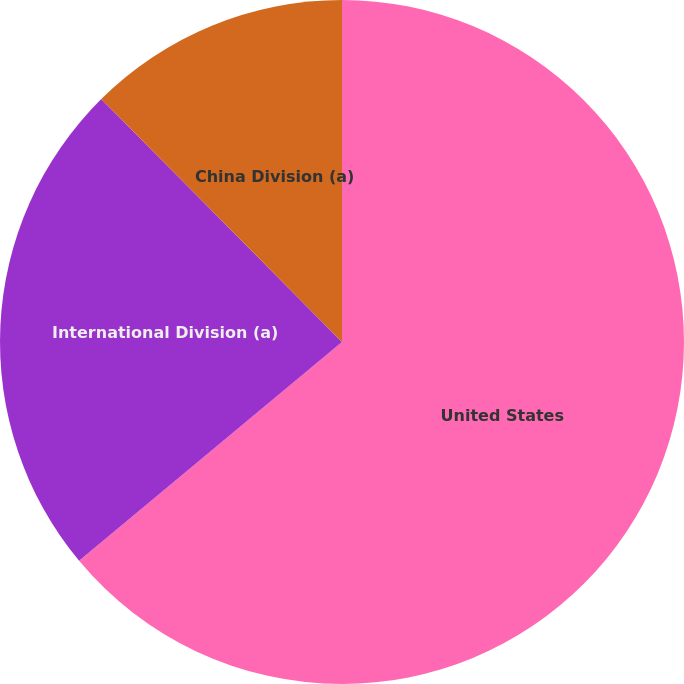Convert chart to OTSL. <chart><loc_0><loc_0><loc_500><loc_500><pie_chart><fcel>United States<fcel>International Division (a)<fcel>China Division (a)<nl><fcel>63.96%<fcel>23.62%<fcel>12.43%<nl></chart> 